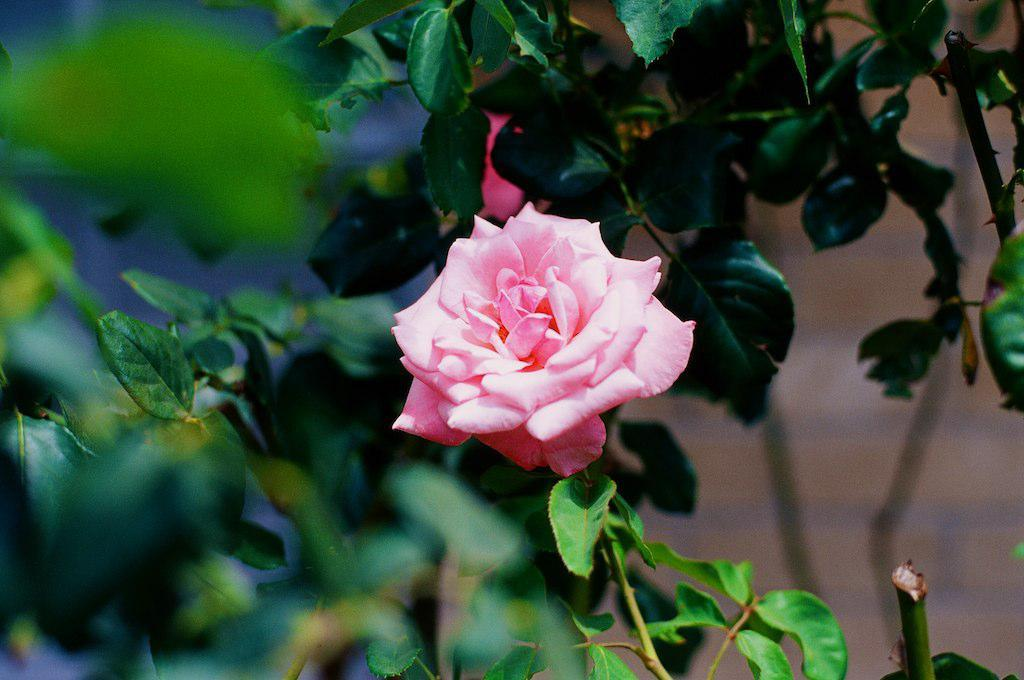What type of flower is in the image? There is a pink rose in the image. What color are the leaf branches in the image? The leaf branches in the image are green. How many geese are flying over the pink rose in the image? There are no geese present in the image; it only features a pink rose and green leaf branches. 